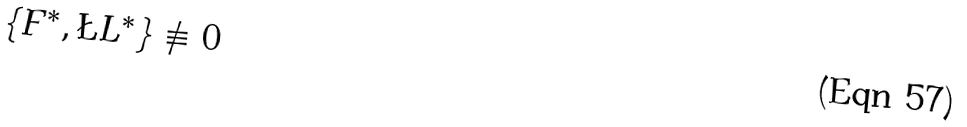Convert formula to latex. <formula><loc_0><loc_0><loc_500><loc_500>\{ F ^ { * } , \L L ^ { * } \} \not \equiv 0</formula> 